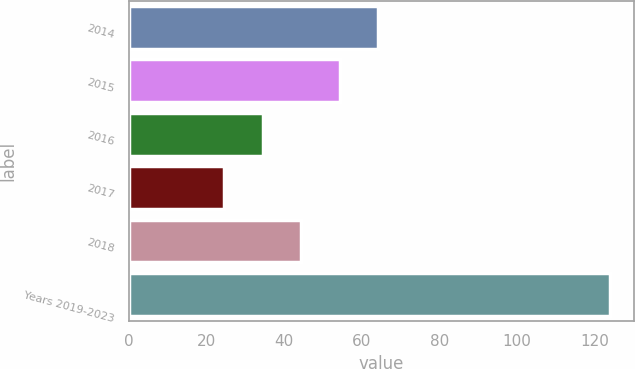<chart> <loc_0><loc_0><loc_500><loc_500><bar_chart><fcel>2014<fcel>2015<fcel>2016<fcel>2017<fcel>2018<fcel>Years 2019-2023<nl><fcel>64.32<fcel>54.39<fcel>34.53<fcel>24.6<fcel>44.46<fcel>123.9<nl></chart> 